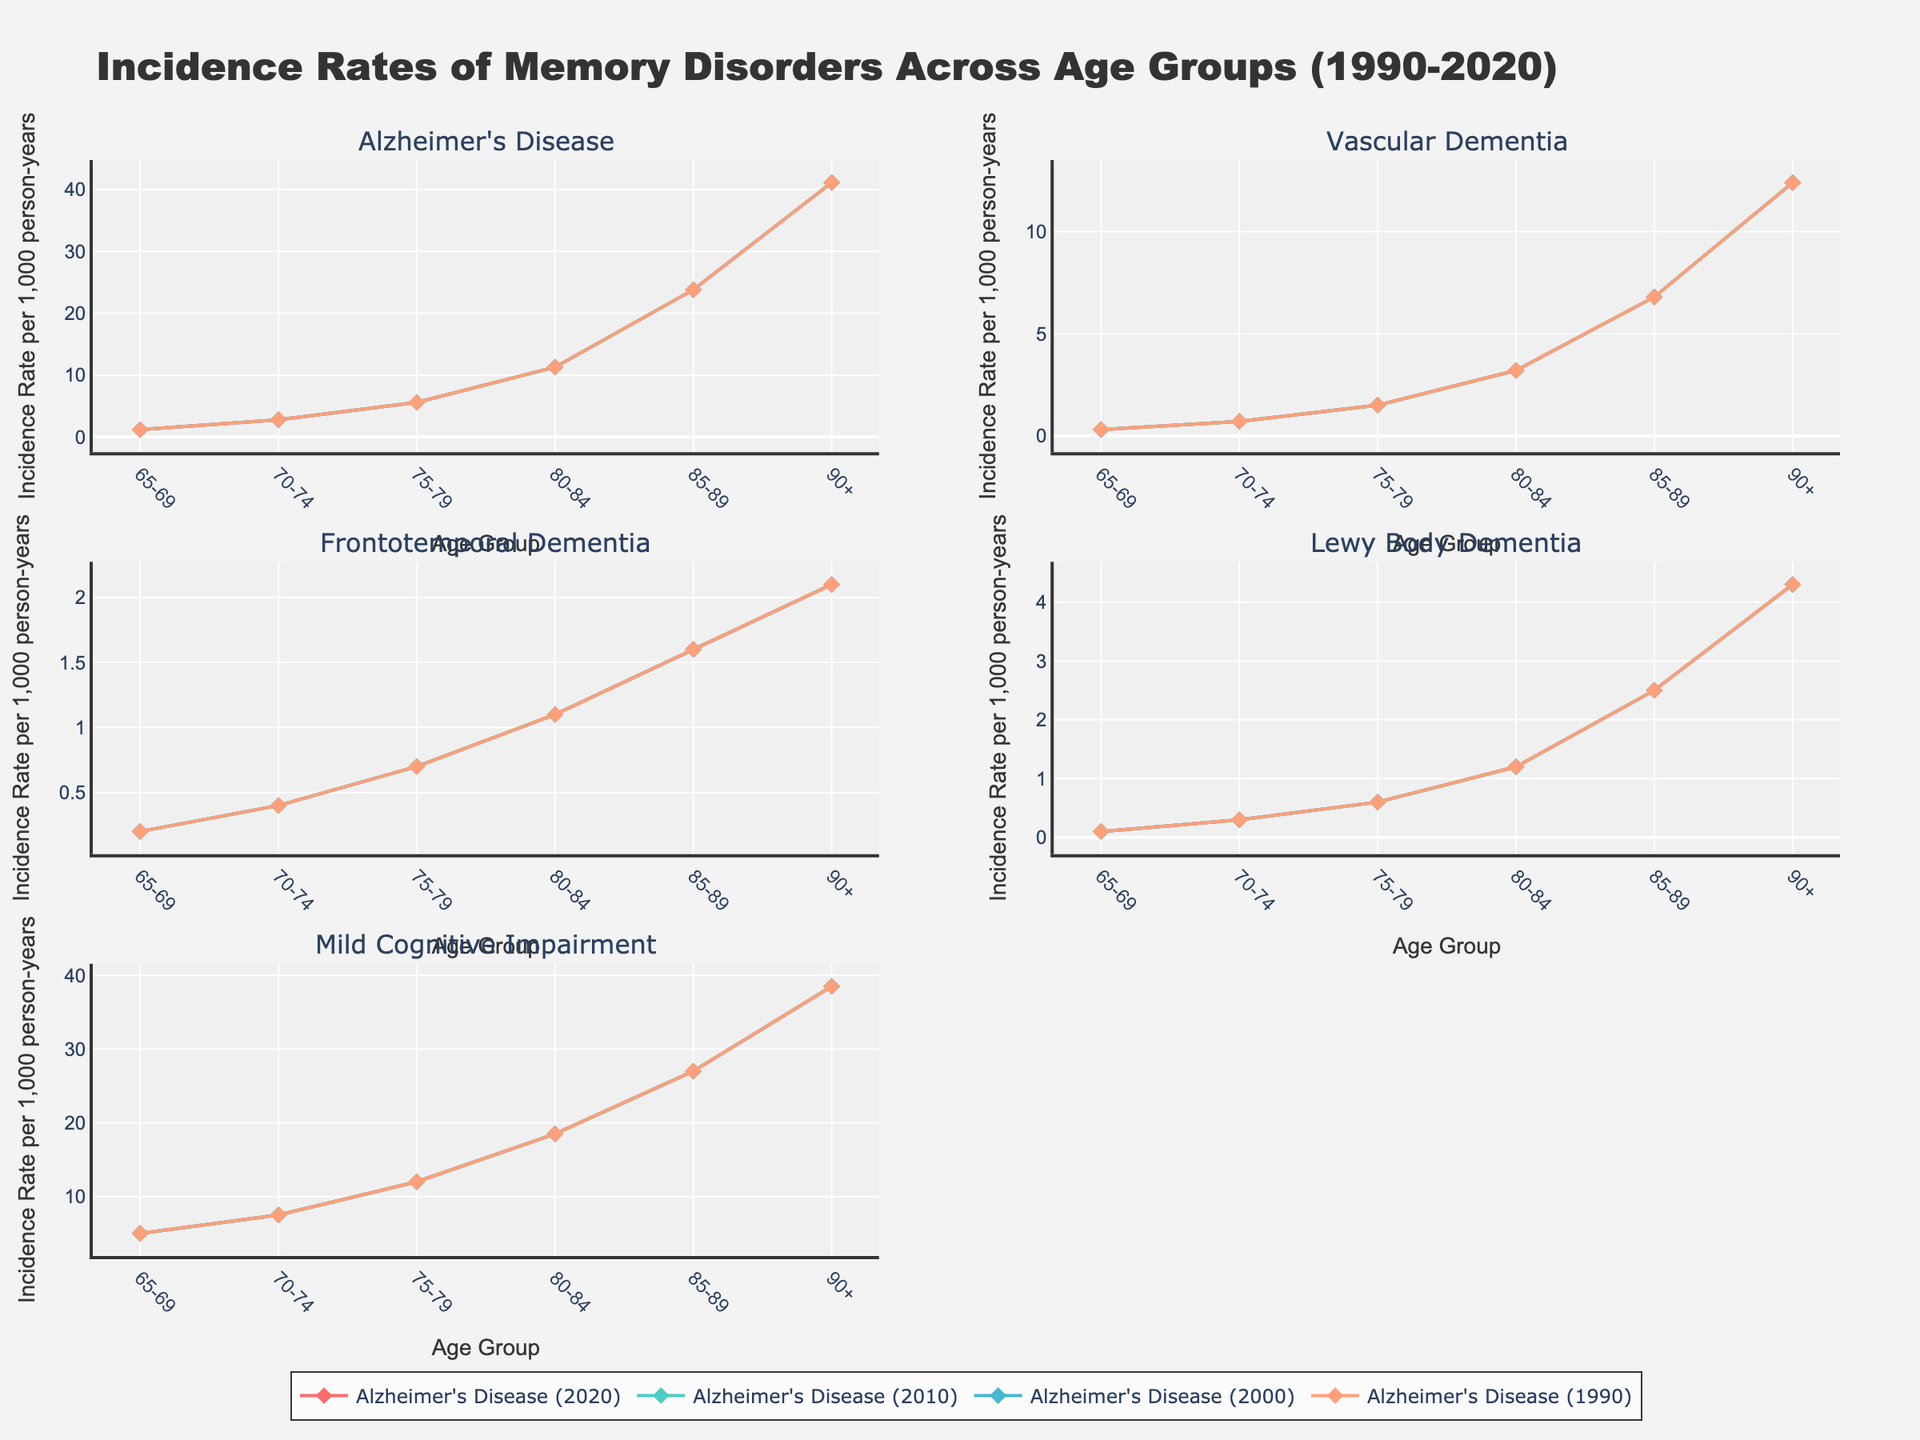What is the trend of incidence rates of Alzheimer's Disease from age group 65-69 to 90+ across the years shown? To answer this, observe the lines for Alzheimer's Disease in each subplot. For all years (1990, 2000, 2010, 2020), the incidence rate increases with age. The trend is consistent over time, with a higher rate for older age groups.
Answer: All years show an increasing trend Which disorder shows the steepest increase in incidence rates between the age groups 85-89 and 90+ in the year 2020? Compare the slopes of the lines for each disorder between these age groups in the 2020 traces. The line for Alzheimer's Disease has the steepest slope, indicating a significant increase.
Answer: Alzheimer's Disease Between the age groups 75-79 and 80-84, which disorder shows the least change in incidence rates in the year 2000? Check the line segments for each disorder between these age groups in the 2000 subplot. The line for Frontotemporal Dementia remains relatively flat, indicating minimal change.
Answer: Frontotemporal Dementia Compare the incidence rates of Mild Cognitive Impairment for the age group 65-69 between 1990 and 2020. What is the difference? Locate the points for Mild Cognitive Impairment at the age group 65-69 in both the 1990 and 2020 sublines. Subtract the 1990 value (3.8) from the 2020 value (5.0).
Answer: 1.2 What is the average incidence rate of Vascular Dementia in the age groups 80-84 and 85-89 for the year 2010? Find the values for Vascular Dementia in these age groups for 2010 (3.0 and 6.3). Sum these values and divide by 2 to get the average.
Answer: 4.65 What disorder had an incidence rate of approximately 12 per 1,000 person-years for age group 90+ in the year 1990, marked by the diamond symbol? Look for the disorder lines ending near the value of 12 for age group 90+ in the 1990 subplot. Frontotemporal Dementia has a value close to 12 and is marked by a diamond.
Answer: Frontotemporal Dementia Which disorder saw a decrease in the incidence rate from 1990 to 2000 for the age group 85-89? Compare the 1990 and 2000 lines for each disorder at the age group 85-89. Lewy Body Dementia shows a decrease from 1.9 to 2.1.
Answer: Lewy Body Dementia How does the incidence rate of Mild Cognitive Impairment for the age group 70-74 compare between 2000 and 2010? Compare the line points for Mild Cognitive Impairment at age group 70-74 for the years 2000 and 2010. The incidence rate increased from 6.4 to 7.0.
Answer: Increased from 6.4 to 7.0 Which disorder's incidence rates in the age group 65-69 are closest to those in the age group 70-74 for the year 2020? Examine the 2020 lines and find the disorders whose 65-69 and 70-74 rates are closest. Frontotemporal Dementia has similar rates (0.2 and 0.4 respectively).
Answer: Frontotemporal Dementia 